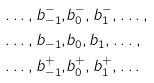Convert formula to latex. <formula><loc_0><loc_0><loc_500><loc_500>\dots , b ^ { - } _ { - 1 } , & b ^ { - } _ { 0 } , b ^ { - } _ { 1 } , \dots , \\ \dots , b _ { - 1 } , & b _ { 0 } , b _ { 1 } , \dots , \\ \dots , b ^ { + } _ { - 1 } , & b ^ { + } _ { 0 } , b ^ { + } _ { 1 } , \dots</formula> 